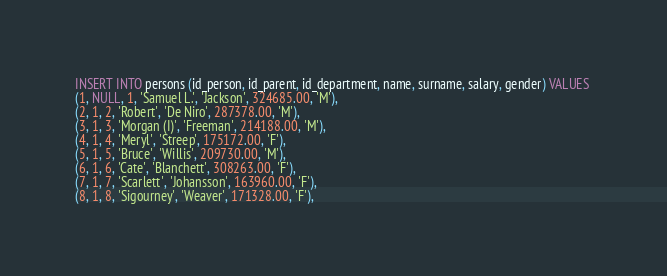Convert code to text. <code><loc_0><loc_0><loc_500><loc_500><_SQL_>INSERT INTO persons (id_person, id_parent, id_department, name, surname, salary, gender) VALUES 
(1, NULL, 1, 'Samuel L.', 'Jackson', 324685.00, 'M'),
(2, 1, 2, 'Robert', 'De Niro', 287378.00, 'M'),
(3, 1, 3, 'Morgan (I)', 'Freeman', 214188.00, 'M'),
(4, 1, 4, 'Meryl', 'Streep', 175172.00, 'F'),
(5, 1, 5, 'Bruce', 'Willis', 209730.00, 'M'),
(6, 1, 6, 'Cate', 'Blanchett', 308263.00, 'F'),
(7, 1, 7, 'Scarlett', 'Johansson', 163960.00, 'F'),
(8, 1, 8, 'Sigourney', 'Weaver', 171328.00, 'F'),</code> 